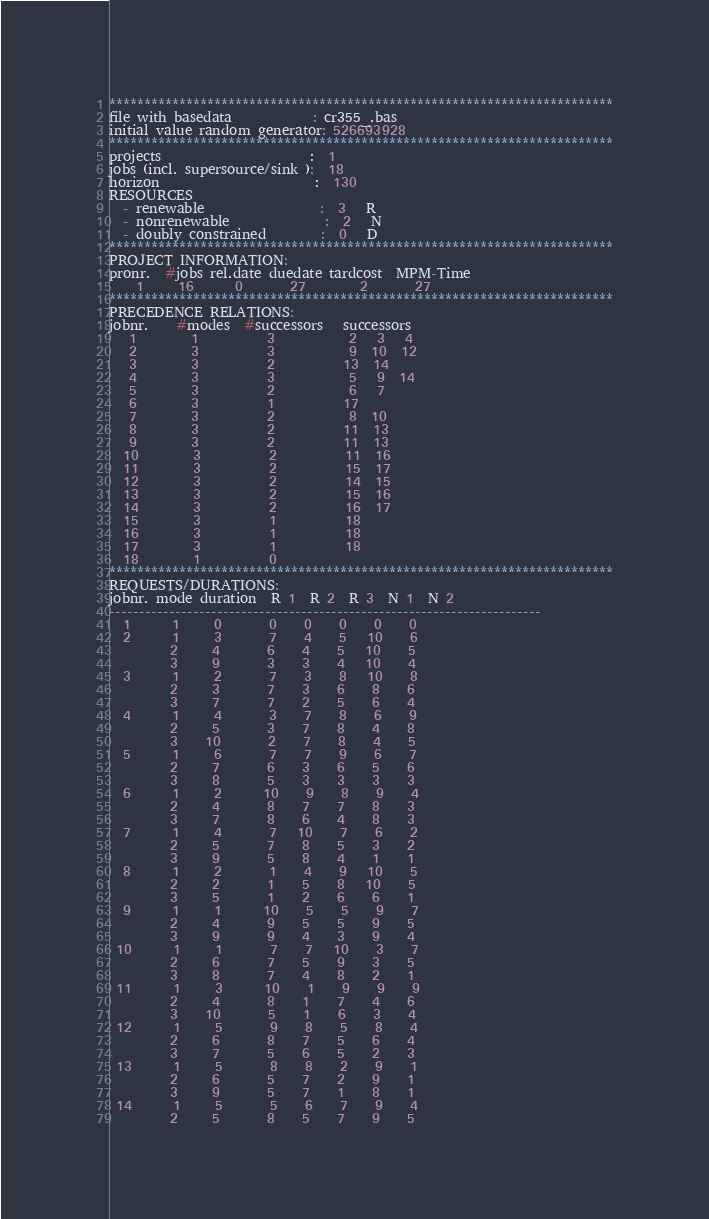Convert code to text. <code><loc_0><loc_0><loc_500><loc_500><_ObjectiveC_>************************************************************************
file with basedata            : cr355_.bas
initial value random generator: 526693928
************************************************************************
projects                      :  1
jobs (incl. supersource/sink ):  18
horizon                       :  130
RESOURCES
  - renewable                 :  3   R
  - nonrenewable              :  2   N
  - doubly constrained        :  0   D
************************************************************************
PROJECT INFORMATION:
pronr.  #jobs rel.date duedate tardcost  MPM-Time
    1     16      0       27        2       27
************************************************************************
PRECEDENCE RELATIONS:
jobnr.    #modes  #successors   successors
   1        1          3           2   3   4
   2        3          3           9  10  12
   3        3          2          13  14
   4        3          3           5   9  14
   5        3          2           6   7
   6        3          1          17
   7        3          2           8  10
   8        3          2          11  13
   9        3          2          11  13
  10        3          2          11  16
  11        3          2          15  17
  12        3          2          14  15
  13        3          2          15  16
  14        3          2          16  17
  15        3          1          18
  16        3          1          18
  17        3          1          18
  18        1          0        
************************************************************************
REQUESTS/DURATIONS:
jobnr. mode duration  R 1  R 2  R 3  N 1  N 2
------------------------------------------------------------------------
  1      1     0       0    0    0    0    0
  2      1     3       7    4    5   10    6
         2     4       6    4    5   10    5
         3     9       3    3    4   10    4
  3      1     2       7    3    8   10    8
         2     3       7    3    6    8    6
         3     7       7    2    5    6    4
  4      1     4       3    7    8    6    9
         2     5       3    7    8    4    8
         3    10       2    7    8    4    5
  5      1     6       7    7    9    6    7
         2     7       6    3    6    5    6
         3     8       5    3    3    3    3
  6      1     2      10    9    8    9    4
         2     4       8    7    7    8    3
         3     7       8    6    4    8    3
  7      1     4       7   10    7    6    2
         2     5       7    8    5    3    2
         3     9       5    8    4    1    1
  8      1     2       1    4    9   10    5
         2     2       1    5    8   10    5
         3     5       1    2    6    6    1
  9      1     1      10    5    5    9    7
         2     4       9    5    5    9    5
         3     9       9    4    3    9    4
 10      1     1       7    7   10    3    7
         2     6       7    5    9    3    5
         3     8       7    4    8    2    1
 11      1     3      10    1    9    9    9
         2     4       8    1    7    4    6
         3    10       5    1    6    3    4
 12      1     5       9    8    5    8    4
         2     6       8    7    5    6    4
         3     7       5    6    5    2    3
 13      1     5       8    8    2    9    1
         2     6       5    7    2    9    1
         3     9       5    7    1    8    1
 14      1     5       5    6    7    9    4
         2     5       8    5    7    9    5</code> 